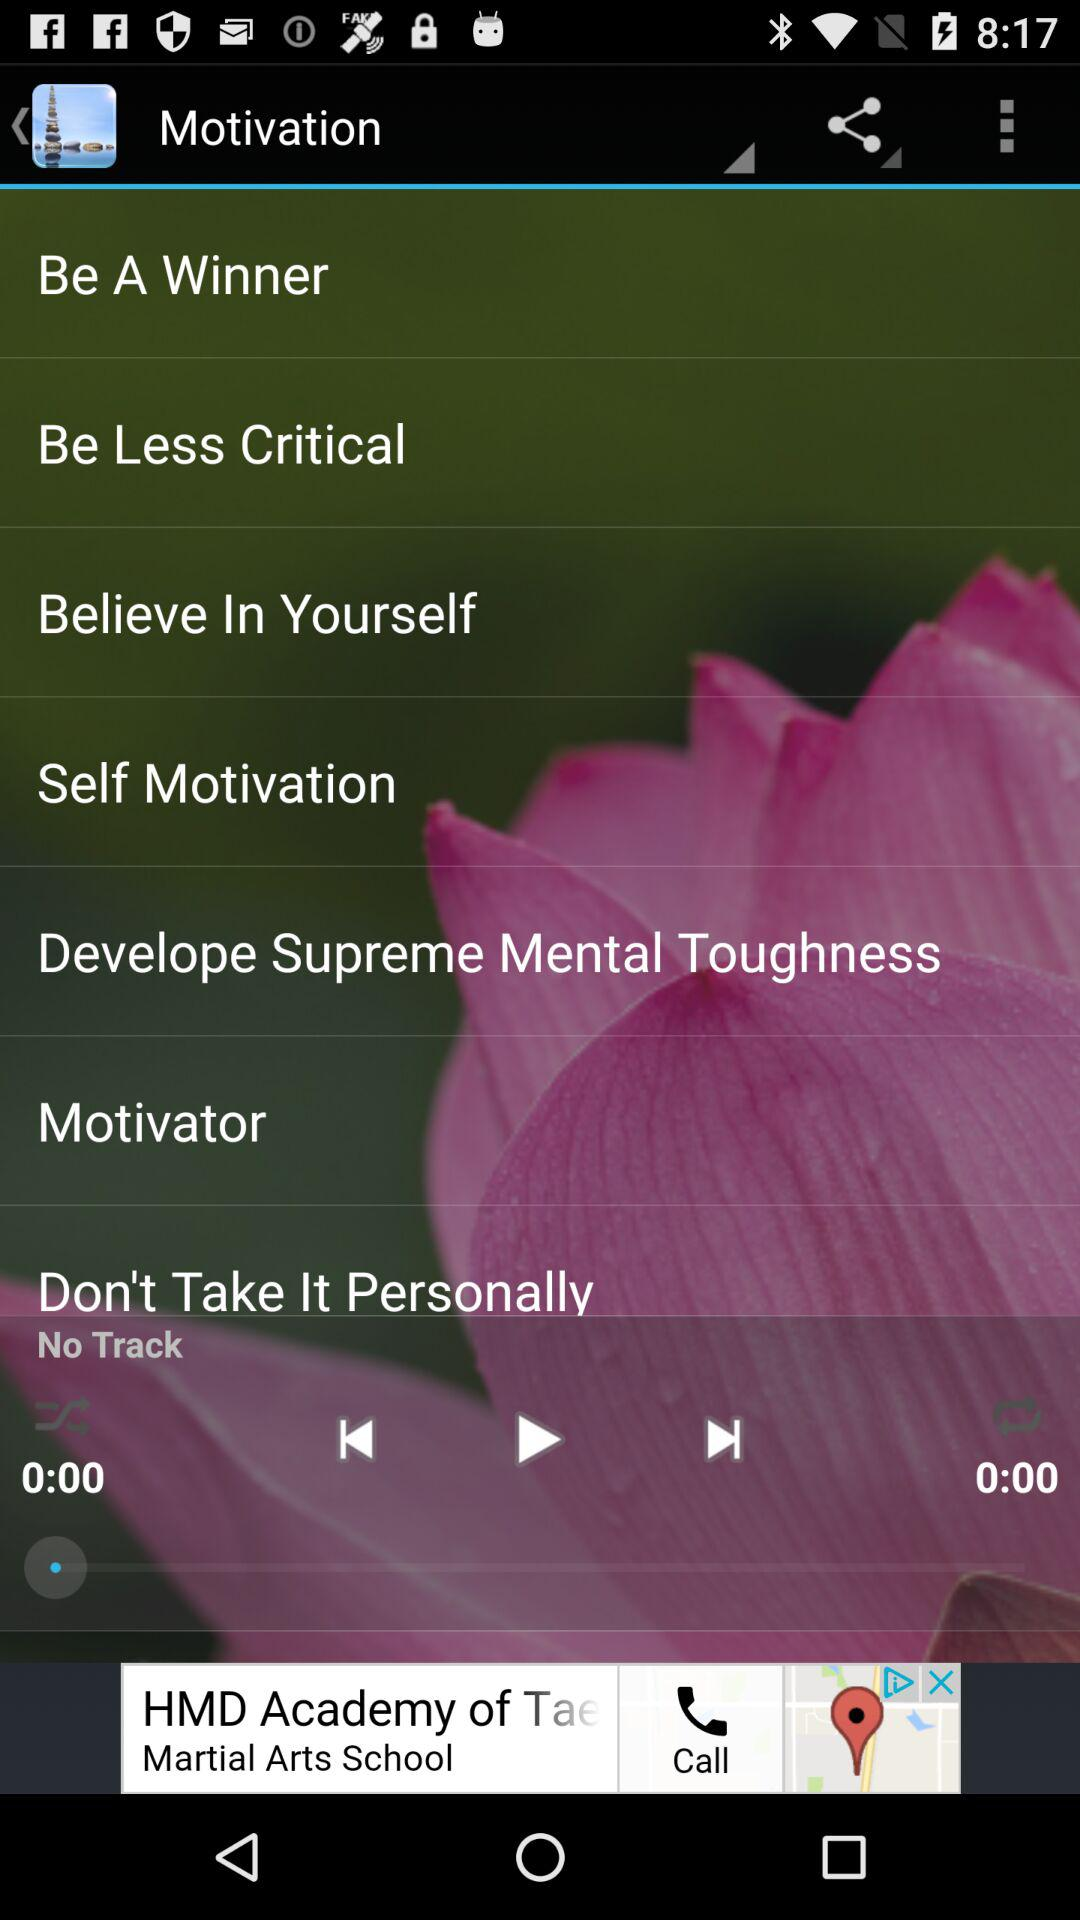Which song is paused?
When the provided information is insufficient, respond with <no answer>. <no answer> 